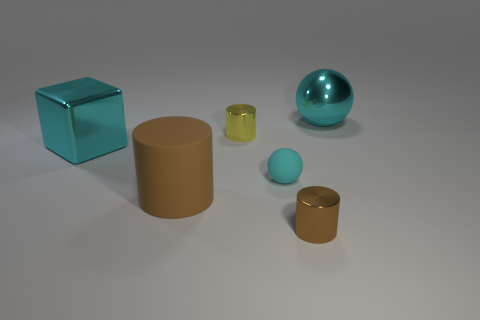Is there a tiny red ball made of the same material as the small cyan sphere?
Your response must be concise. No. What number of things are metal cylinders that are behind the big cylinder or large purple objects?
Ensure brevity in your answer.  1. Is the material of the tiny yellow object that is behind the cyan metal block the same as the big brown object?
Your answer should be very brief. No. Is the shape of the cyan rubber object the same as the large brown thing?
Offer a very short reply. No. There is a tiny matte ball on the right side of the large matte object; what number of small metallic objects are to the left of it?
Make the answer very short. 1. There is another tiny object that is the same shape as the small brown metallic thing; what is it made of?
Make the answer very short. Metal. There is a small metal thing in front of the large brown object; does it have the same color as the matte cylinder?
Make the answer very short. Yes. Is the yellow thing made of the same material as the big cube behind the brown rubber cylinder?
Ensure brevity in your answer.  Yes. What is the shape of the large cyan object left of the big rubber thing?
Provide a short and direct response. Cube. How many other objects are the same material as the big block?
Offer a very short reply. 3. 